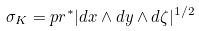Convert formula to latex. <formula><loc_0><loc_0><loc_500><loc_500>\sigma _ { K } = p r ^ { * } | d x \wedge d y \wedge d \zeta | ^ { 1 / 2 }</formula> 